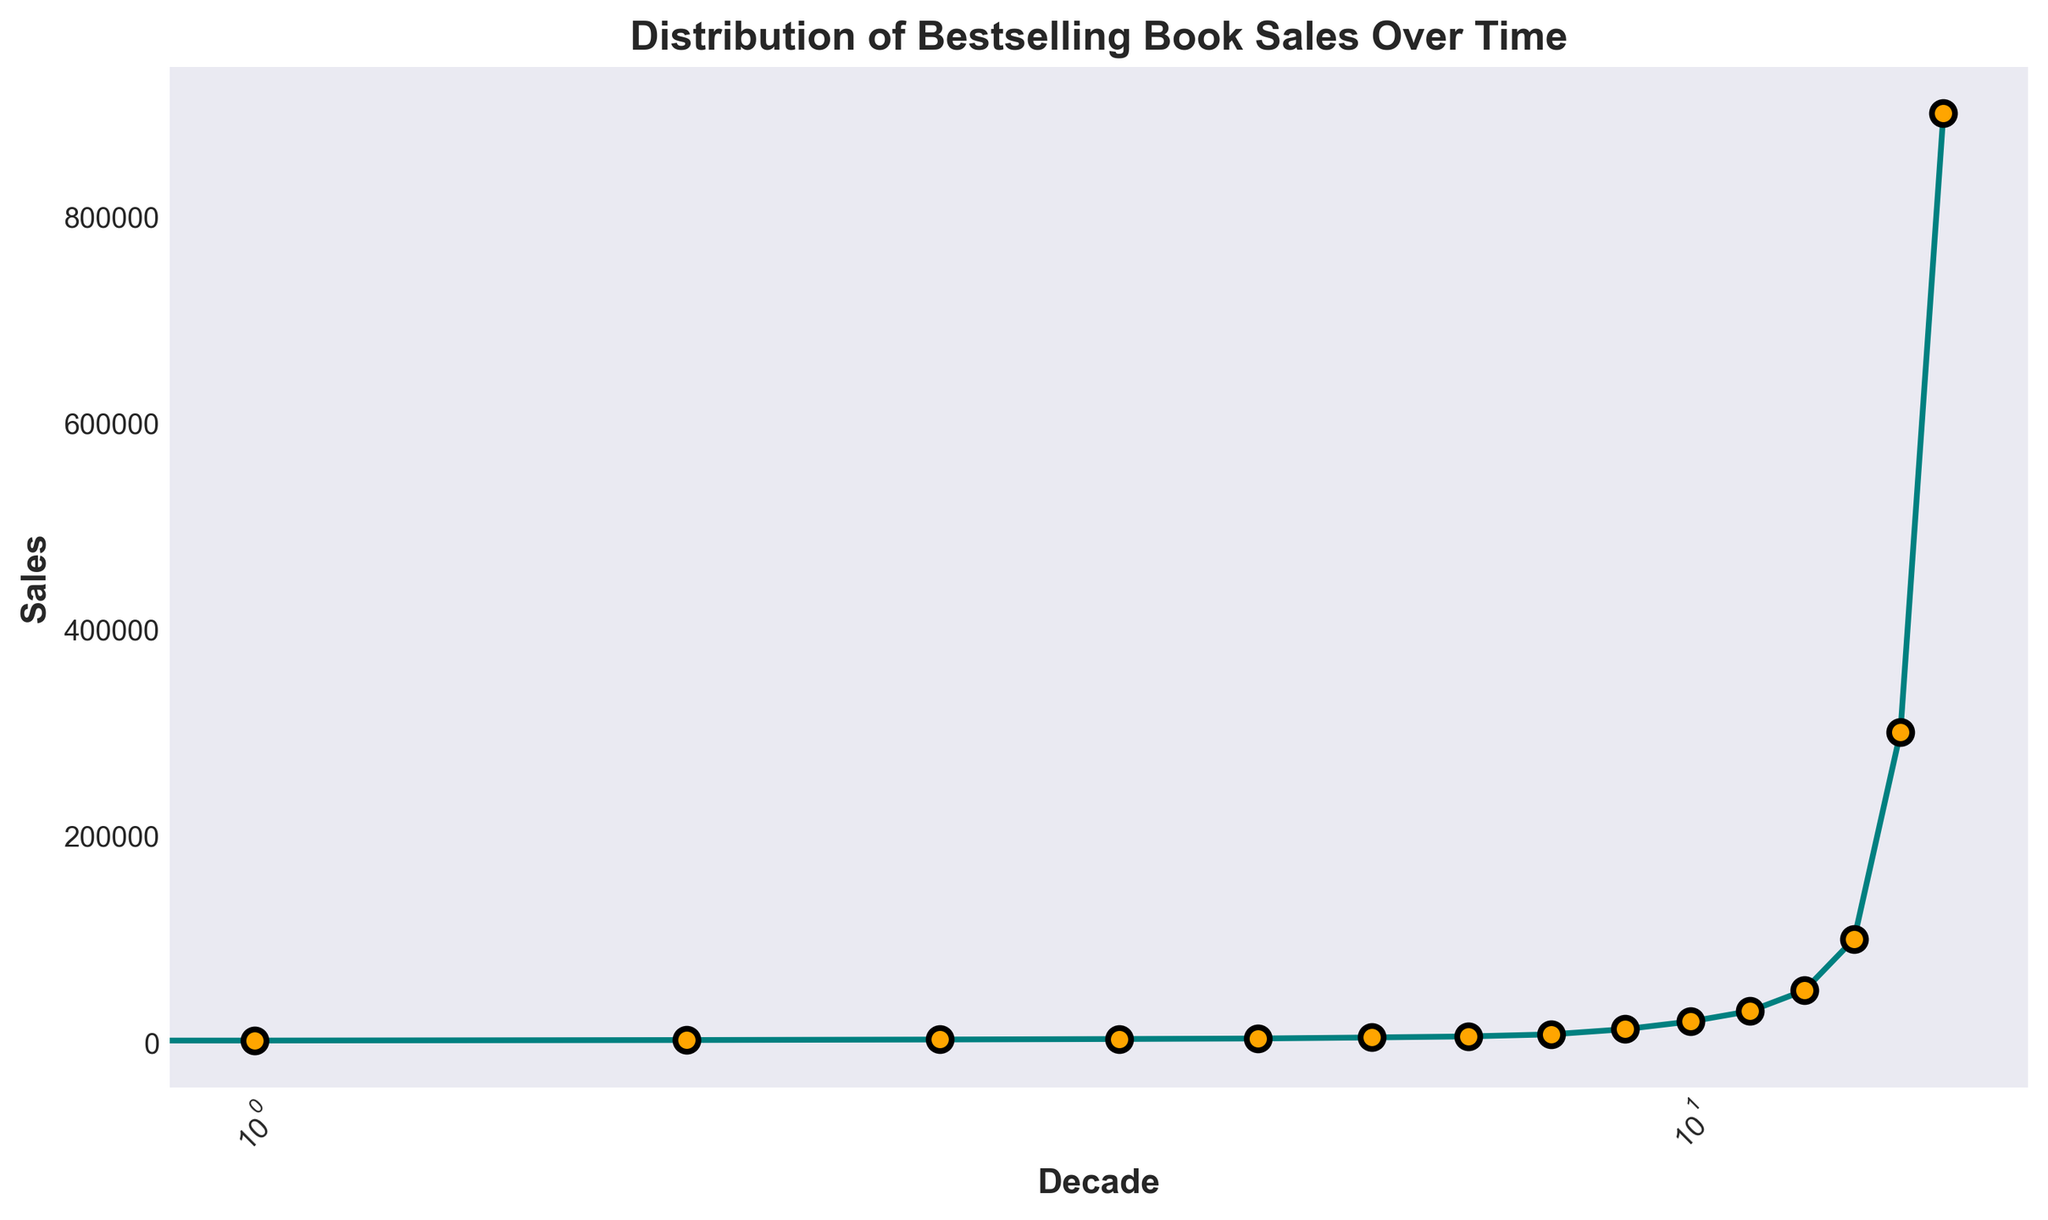What's the trend in bestselling book sales over the decades? By observing the plotted data, we can see the progression of sales over time. The sales figures consistently increase from the 1870s to the 2020s, indicating a clear upward trend.
Answer: Increasing trend Which decade saw the first significant jump in sales compared to the previous decade? The first significant jump in sales occurs between the 1950s (7,500 sales) and the 1960s (12,500 sales), marking an increase of 5,000 sales.
Answer: 1960s What is the sales difference between the 1980s and the 1990s? Sales in the 1980s were 30,000, while in the 1990s they were 50,000. To find the difference, we subtract 30,000 from 50,000, which equals 20,000.
Answer: 20,000 During which decade did book sales reach 100,000? By examining the plotted data points, we observe that sales in the 2000s reached 100,000.
Answer: 2000s How much did sales increase between the 2000s and the 2010s? Sales in the 2000s were 100,000, and in the 2010s, they were 300,000. The increase is calculated by subtracting 100,000 from 300,000, resulting in an increase of 200,000.
Answer: 200,000 What is the visual relationship between decade and sales on the logscale x-axis? Visually, the x-axis uses a logarithmic scale, indicating the decades, while the y-axis represents the sales. This logscale compresses the spread of the earlier decades and expands the latter ones, emphasizing the exponential growth in sales over recent decades. This transformation makes the incremental increase in sales more noticeable.
Answer: Logarithmic compression of earlier decades, exponential spread of latter ones Which two consecutive decades have the biggest difference in sales on the plot? The biggest difference in sales between two consecutive decades occurs between the 2010s (300,000 sales) and the 2020s (900,000 sales). The difference is 600,000.
Answer: 2010s and 2020s Is there a decade where sales did not increase compared to its preceding decade? Observing the plotted data, each decade shows an increase in sales compared to its preceding decade. Therefore, there is no decade where sales did not increase.
Answer: No How do the sales in the 1930s compare to those in the 1920s? In the 1930s, sales were 4,500, while in the 1920s, they were 3,500. This shows an increase of 1,000 sales from the 1920s to the 1930s.
Answer: 1,000 increase What pattern of growth can be observed in the later decades (from the 1980s onward)? From the 1980s onward, the pattern shows an exponentially increasing trend, with a steeper rise in sales. The sales figures go from 30,000 in the 1980s to 50,000 in the 1990s, to 100,000 in the 2000s, to 300,000 in the 2010s, and to 900,000 in the 2020s.
Answer: Exponential growth 